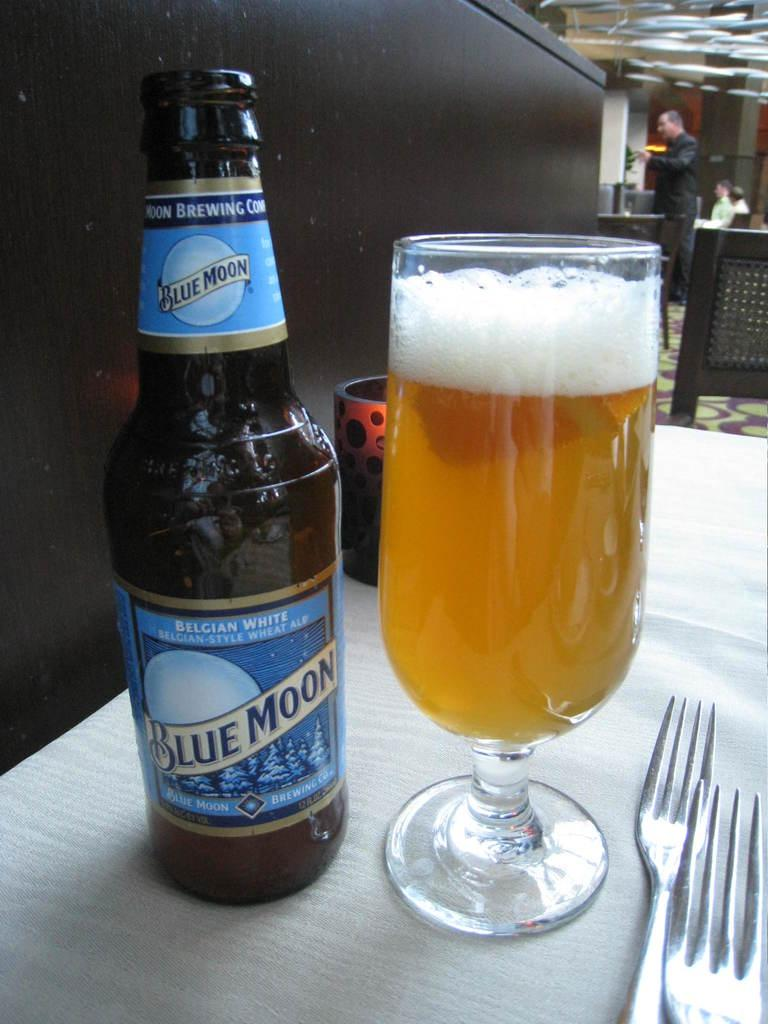<image>
Share a concise interpretation of the image provided. Glass of beer sitting next to a bottle of Blue Moon Ale on a table. 